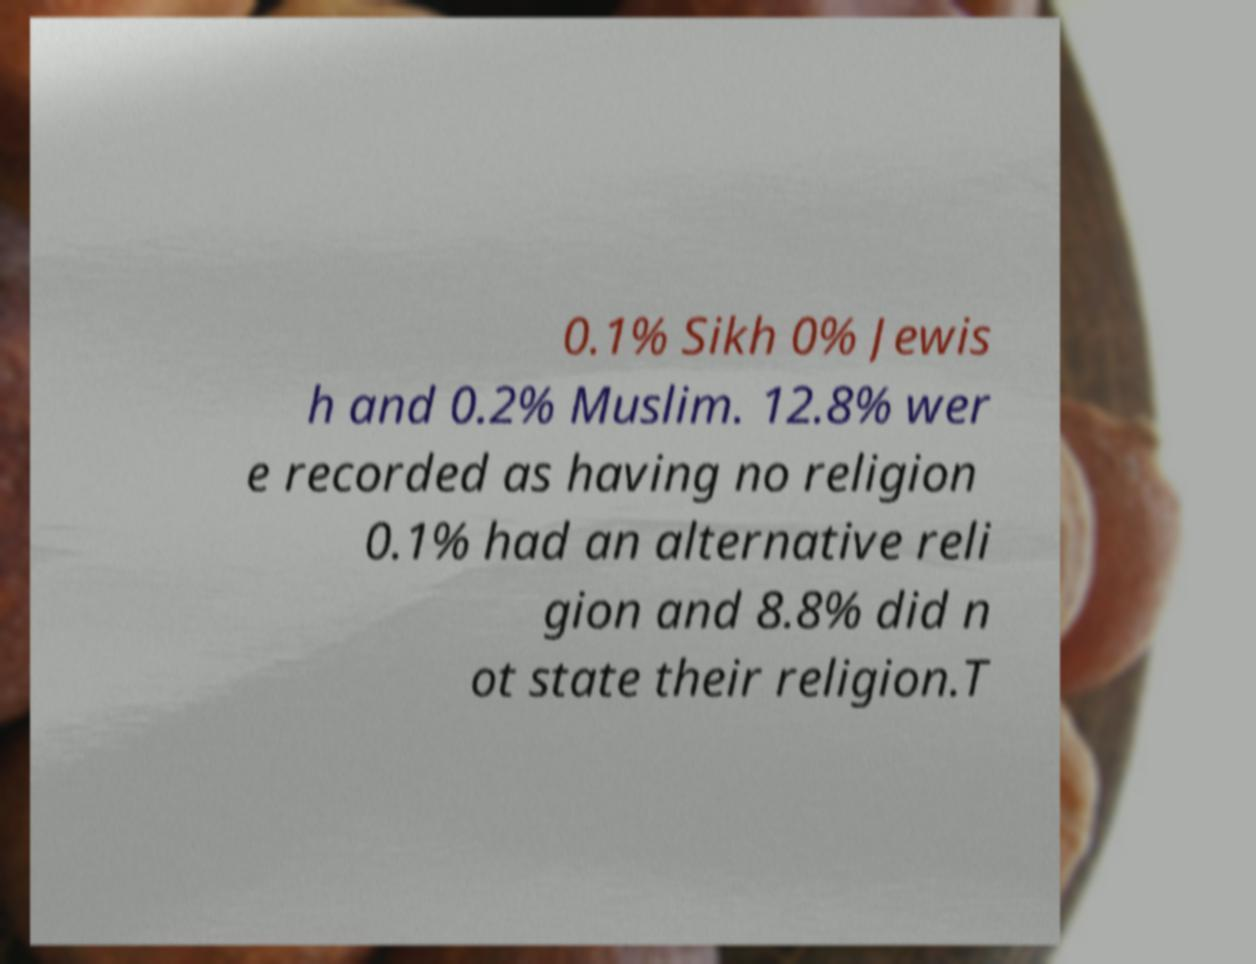Can you read and provide the text displayed in the image?This photo seems to have some interesting text. Can you extract and type it out for me? 0.1% Sikh 0% Jewis h and 0.2% Muslim. 12.8% wer e recorded as having no religion 0.1% had an alternative reli gion and 8.8% did n ot state their religion.T 